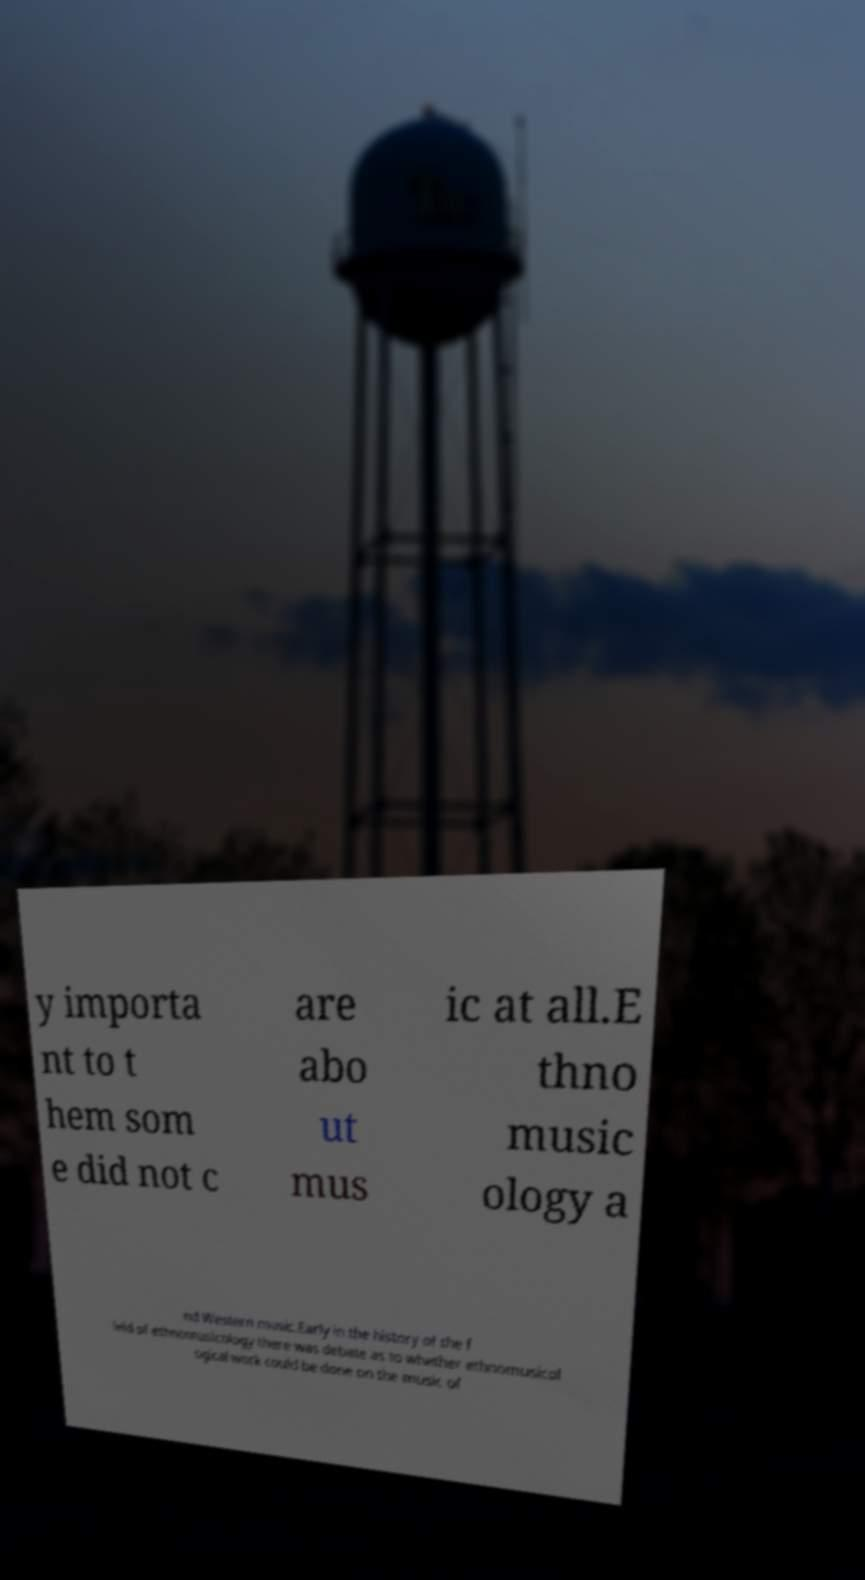Please read and relay the text visible in this image. What does it say? y importa nt to t hem som e did not c are abo ut mus ic at all.E thno music ology a nd Western music.Early in the history of the f ield of ethnomusicology there was debate as to whether ethnomusicol ogical work could be done on the music of 